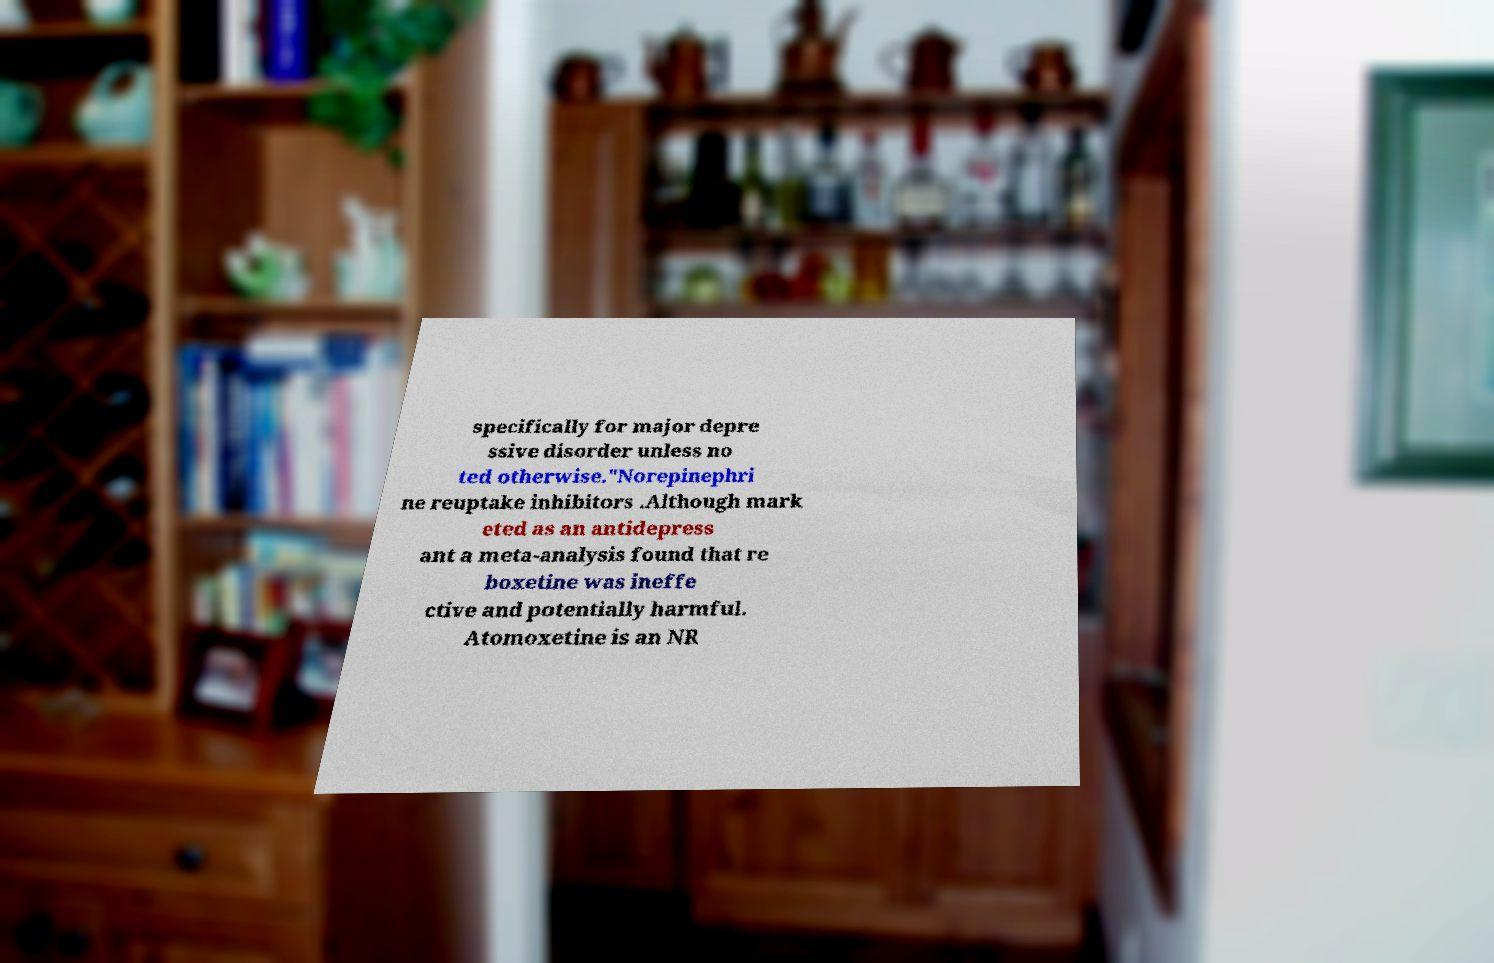For documentation purposes, I need the text within this image transcribed. Could you provide that? specifically for major depre ssive disorder unless no ted otherwise."Norepinephri ne reuptake inhibitors .Although mark eted as an antidepress ant a meta-analysis found that re boxetine was ineffe ctive and potentially harmful. Atomoxetine is an NR 